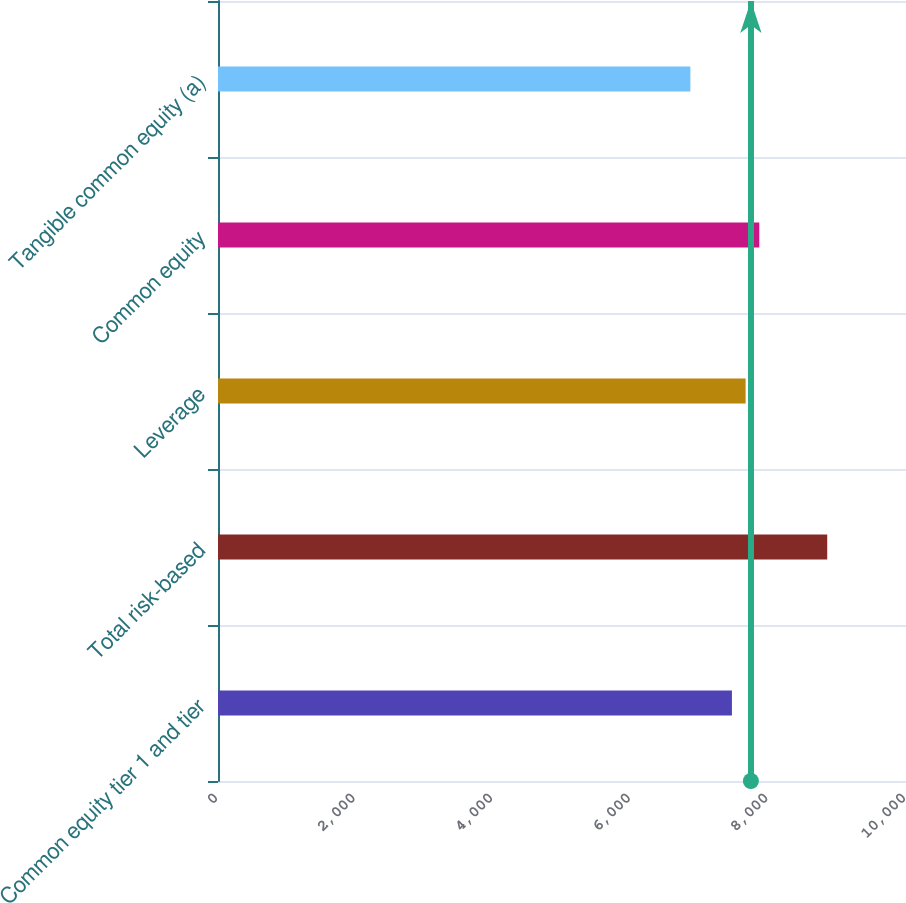Convert chart to OTSL. <chart><loc_0><loc_0><loc_500><loc_500><bar_chart><fcel>Common equity tier 1 and tier<fcel>Total risk-based<fcel>Leverage<fcel>Common equity<fcel>Tangible common equity (a)<nl><fcel>7470<fcel>8855<fcel>7668.9<fcel>7867.8<fcel>6866<nl></chart> 